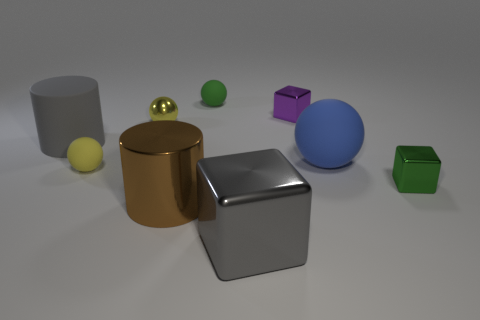Subtract all small cubes. How many cubes are left? 1 Subtract all green cubes. How many cubes are left? 2 Subtract all spheres. How many objects are left? 5 Subtract 4 balls. How many balls are left? 0 Add 1 tiny red metal blocks. How many objects exist? 10 Add 2 green rubber objects. How many green rubber objects exist? 3 Subtract 0 cyan cylinders. How many objects are left? 9 Subtract all green balls. Subtract all gray blocks. How many balls are left? 3 Subtract all cyan cubes. How many yellow spheres are left? 2 Subtract all tiny green rubber objects. Subtract all rubber spheres. How many objects are left? 5 